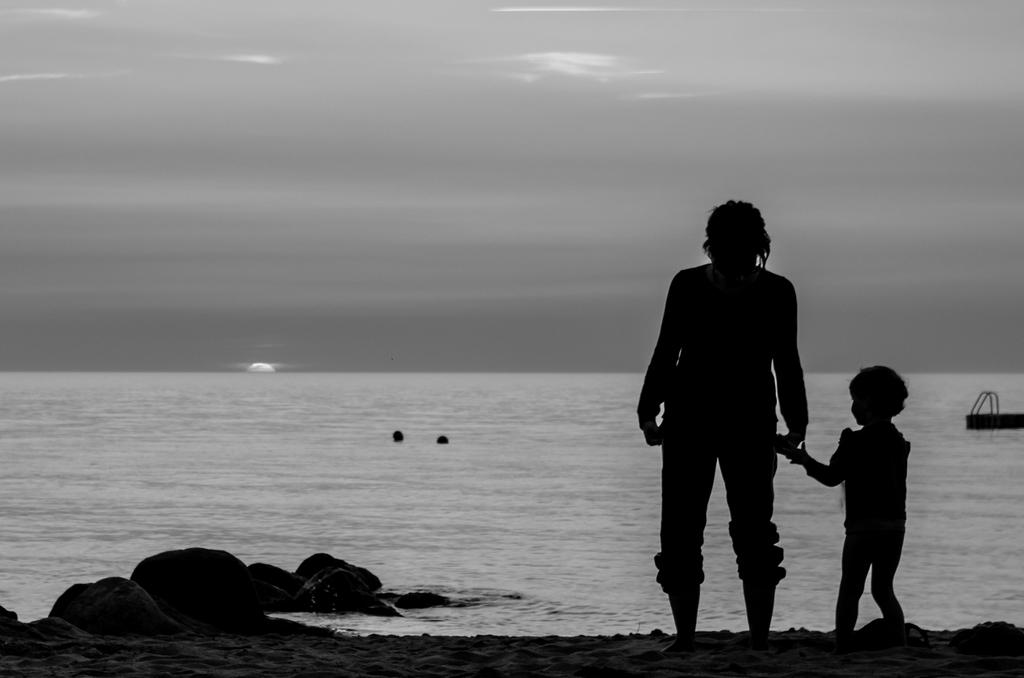What is the primary subject in the image? There is a person standing in the image. Can you describe the person's surroundings? There is a child beside the person in the image, and both are standing on sandstone. What is the child wearing? The child is wearing clothes, just like the person. What else can be seen in the image? There is water and the sky visible in the image. Can you see any feathers floating in the water in the image? There are no feathers visible in the image; it only features a person, a child, sandstone, water, and the sky. 